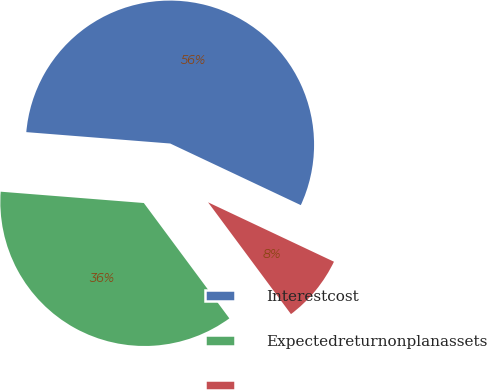<chart> <loc_0><loc_0><loc_500><loc_500><pie_chart><fcel>Interestcost<fcel>Expectedreturnonplanassets<fcel>Unnamed: 2<nl><fcel>55.76%<fcel>36.41%<fcel>7.83%<nl></chart> 